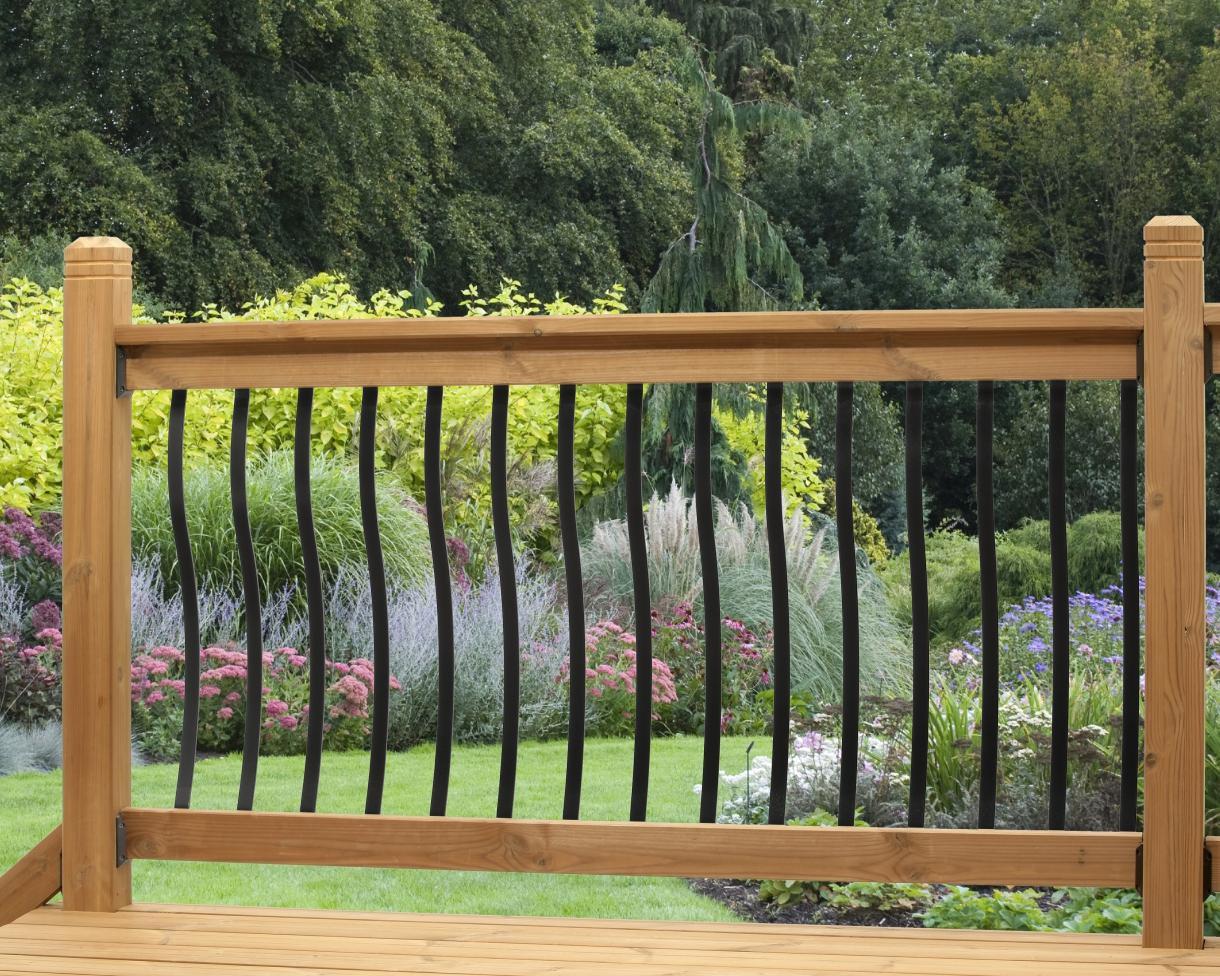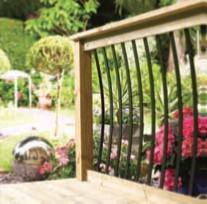The first image is the image on the left, the second image is the image on the right. Assess this claim about the two images: "Flowers and foliage are seen through curving black vertical rails mounted to light wood in both scenes.". Correct or not? Answer yes or no. Yes. 